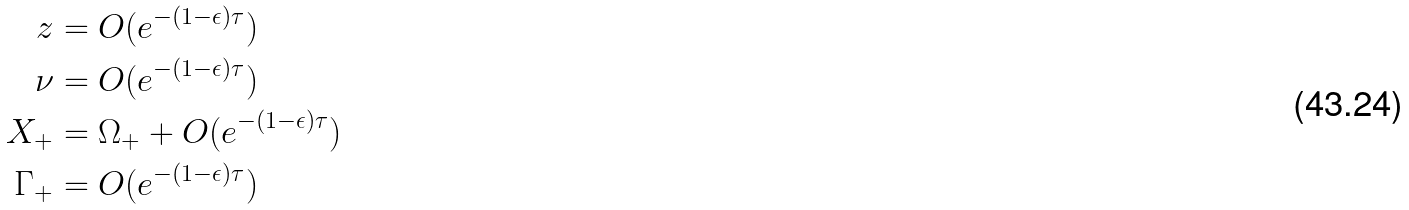Convert formula to latex. <formula><loc_0><loc_0><loc_500><loc_500>z & = O ( e ^ { - ( 1 - \epsilon ) \tau } ) \\ \nu & = O ( e ^ { - ( 1 - \epsilon ) \tau } ) \\ X _ { + } & = \Omega _ { + } + O ( e ^ { - ( 1 - \epsilon ) \tau } ) \\ \Gamma _ { + } & = O ( e ^ { - ( 1 - \epsilon ) \tau } )</formula> 